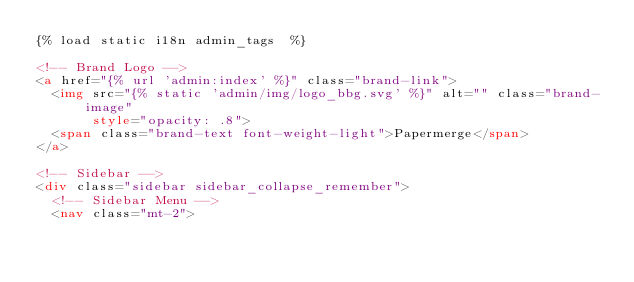Convert code to text. <code><loc_0><loc_0><loc_500><loc_500><_HTML_>{% load static i18n admin_tags  %}

<!-- Brand Logo -->
<a href="{% url 'admin:index' %}" class="brand-link">
  <img src="{% static 'admin/img/logo_bbg.svg' %}" alt="" class="brand-image"
       style="opacity: .8">
  <span class="brand-text font-weight-light">Papermerge</span>
</a>

<!-- Sidebar -->
<div class="sidebar sidebar_collapse_remember">
  <!-- Sidebar Menu -->
  <nav class="mt-2"></code> 